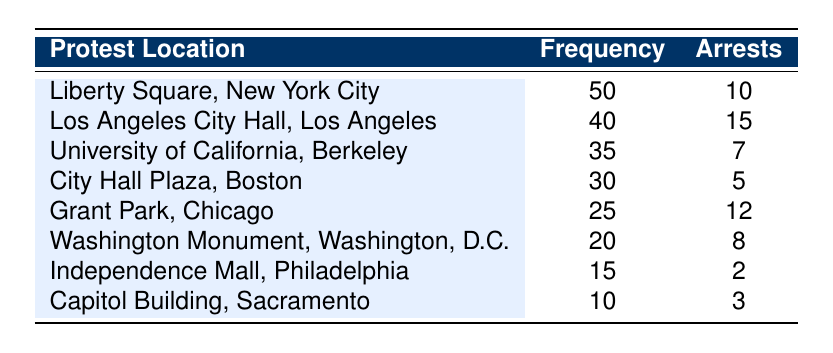What is the highest frequency of protests listed in the table? The table shows the frequency of protests at different locations. Scanning through the frequency column, the highest value is found at Liberty Square, New York City with a frequency of 50.
Answer: 50 Which protest location had the lowest number of arrests? By examining the arrests column of the table, Independence Mall, Philadelphia has the lowest number of arrests listed at 2.
Answer: 2 What is the total number of arrests for all protest locations? To find the total number of arrests, we sum up the arrests for each location: 10 + 15 + 7 + 5 + 12 + 8 + 2 + 3 = 62. Thus, the total number of arrests is 62.
Answer: 62 Is the number of arrests at Los Angeles City Hall greater than the average number of arrests across all locations? First, we calculate the average number of arrests: total arrests (62) divided by the number of locations (8) equals 7.75. Since Los Angeles City Hall has 15 arrests, which is greater than 7.75, the answer is yes.
Answer: Yes What is the difference in frequency between the protest location with the most arrests and the one with the least? The location with the most arrests is Los Angeles City Hall with 15 arrests, while the one with the least is Independence Mall, Philadelphia with 2 arrests. To find the difference in frequency, we take the frequencies: 40 (Los Angeles) - 15 (Independence) = 25. Thus, the frequency difference is 25.
Answer: 25 Which protest location has a frequency lower than 30 but more than 10? Looking through the frequency column, City Hall Plaza, Boston (30) does not qualify since it is not lower than 30, and Capitol Building, Sacramento (10) does not qualify since it is not more than 10. The only location that fulfills the requirement is Grant Park, Chicago with a frequency of 25.
Answer: Grant Park, Chicago What is the ratio of arrests to frequency for the protest location with the highest frequency? Liberty Square, New York City has the highest frequency (50) and the number of arrests (10). To find the ratio, we divide the number of arrests by the frequency: 10/50 = 0.2. This establishes the ratio of arrests to frequency at this location.
Answer: 0.2 Did any protest location have more arrests than the number of protests held? By evaluating the frequencies against the arrests, we note that Los Angeles City Hall has 40 protests and 15 arrests, which means it did have more protests than arrests. However, no location has more arrests than the number of protests held.
Answer: No What is the average frequency of protests across all listed locations? To find the average frequency, sum all frequencies: 50 + 40 + 35 + 30 + 25 + 20 + 15 + 10 = 225. There are 8 locations, so the average frequency is 225 / 8 = 28.125.
Answer: 28.125 